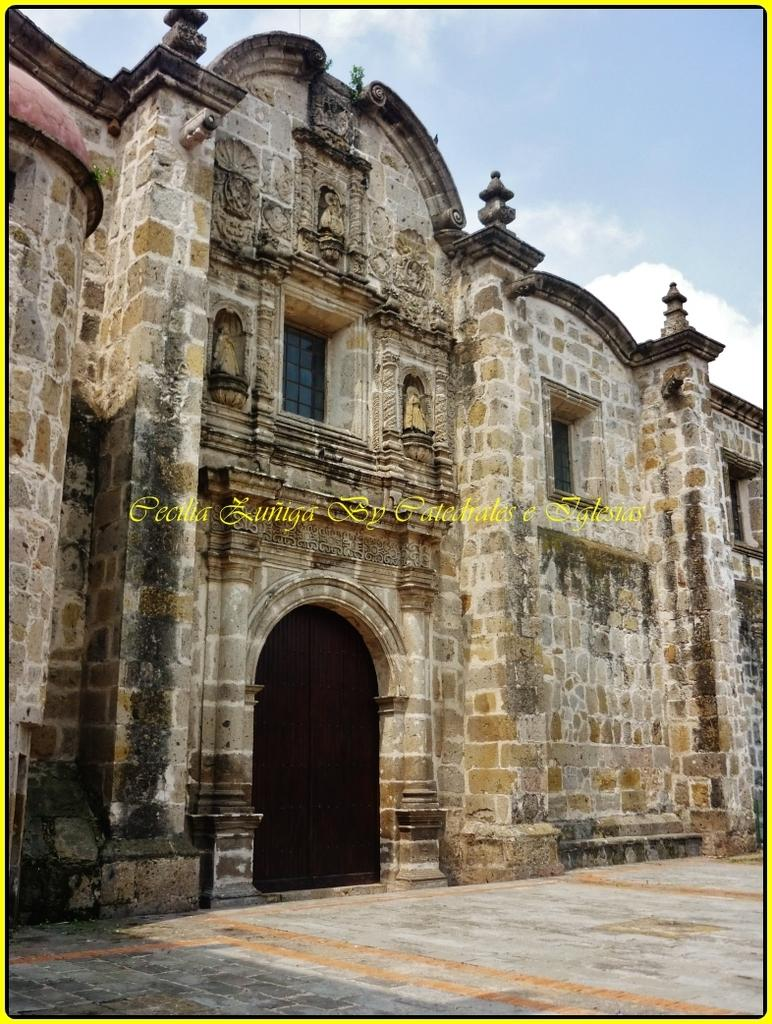What is the main subject of the image? The image appears to depict a monument. What is featured on the monument? There is text in the middle of the monument. What is visible at the top of the image? The sky is visible at the top of the image. How many elbows can be seen on the monument in the image? There are no elbows present on the monument in the image. What type of string is used to hold the text on the monument? There is no mention of string being used to hold the text on the monument in the image. 